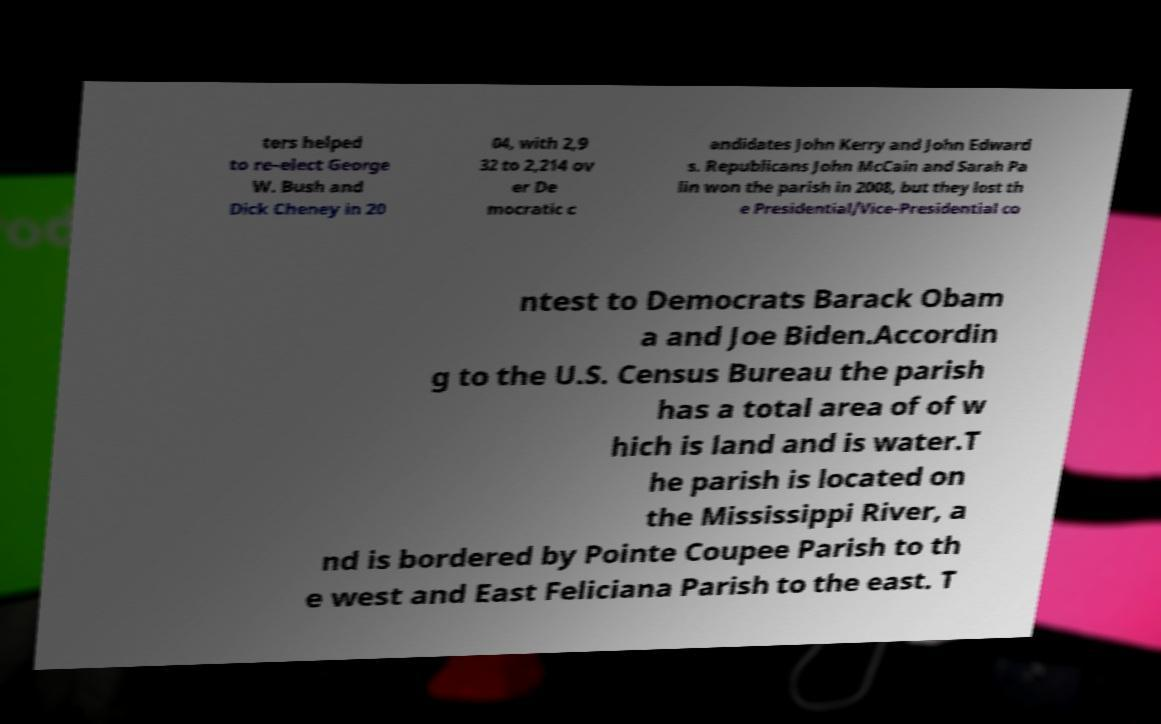Could you assist in decoding the text presented in this image and type it out clearly? ters helped to re-elect George W. Bush and Dick Cheney in 20 04, with 2,9 32 to 2,214 ov er De mocratic c andidates John Kerry and John Edward s. Republicans John McCain and Sarah Pa lin won the parish in 2008, but they lost th e Presidential/Vice-Presidential co ntest to Democrats Barack Obam a and Joe Biden.Accordin g to the U.S. Census Bureau the parish has a total area of of w hich is land and is water.T he parish is located on the Mississippi River, a nd is bordered by Pointe Coupee Parish to th e west and East Feliciana Parish to the east. T 